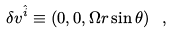Convert formula to latex. <formula><loc_0><loc_0><loc_500><loc_500>\delta v ^ { \hat { i } } \equiv \left ( 0 , 0 , \Omega r \sin \theta \right ) \ ,</formula> 